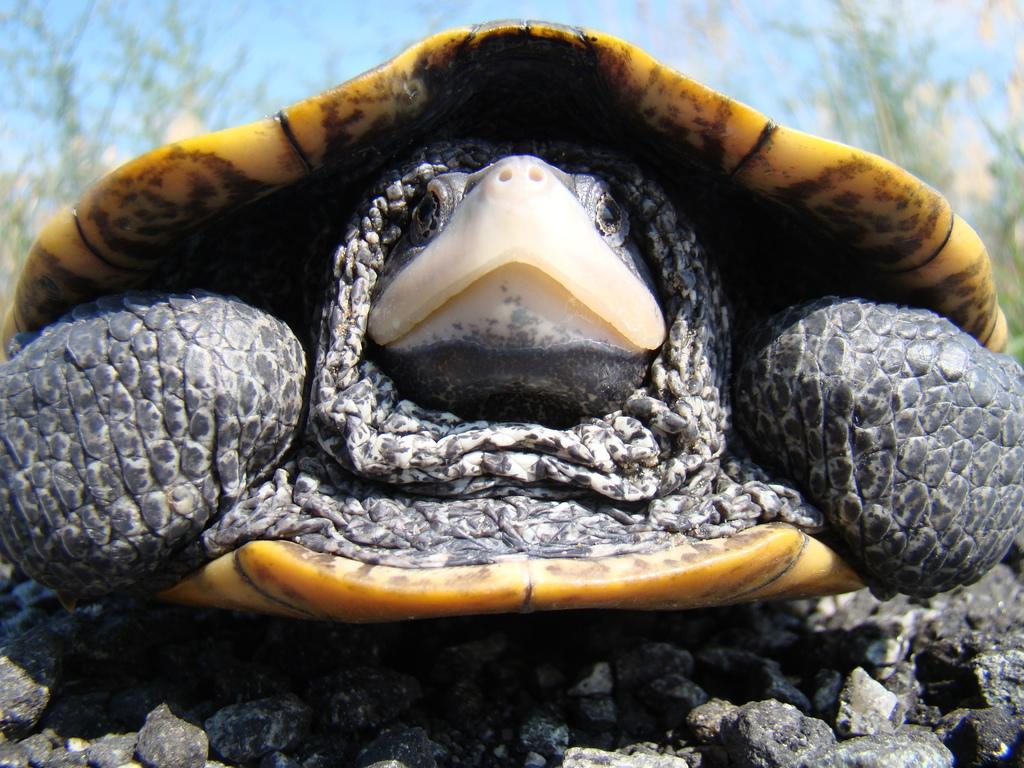What type of animal is in the image? There is a tortoise in the image. What colors can be seen on the tortoise? The tortoise has ash, black, and yellow colors. What type of objects are present in the image? There are stones and green plants in the image. What is the color of the sky in the image? The sky is blue in the image. How does the tortoise express love in the image? There is no indication of love or emotion in the image; it simply shows a tortoise with its colors and the surrounding environment. 